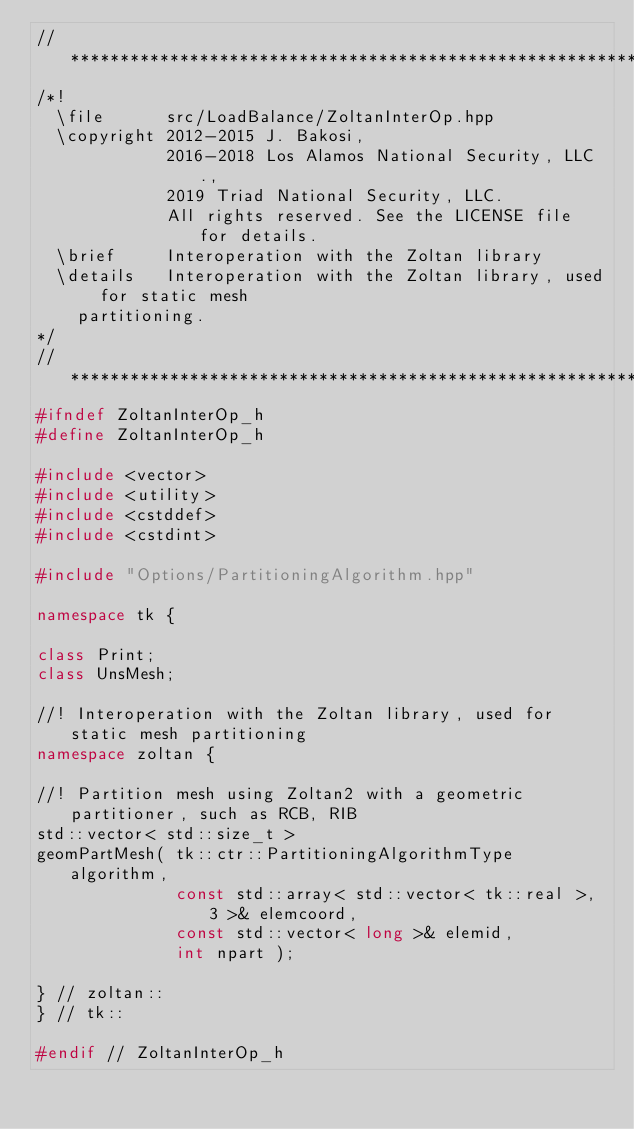<code> <loc_0><loc_0><loc_500><loc_500><_C++_>// *****************************************************************************
/*!
  \file      src/LoadBalance/ZoltanInterOp.hpp
  \copyright 2012-2015 J. Bakosi,
             2016-2018 Los Alamos National Security, LLC.,
             2019 Triad National Security, LLC.
             All rights reserved. See the LICENSE file for details.
  \brief     Interoperation with the Zoltan library
  \details   Interoperation with the Zoltan library, used for static mesh
    partitioning.
*/
// *****************************************************************************
#ifndef ZoltanInterOp_h
#define ZoltanInterOp_h

#include <vector>
#include <utility>
#include <cstddef>
#include <cstdint>

#include "Options/PartitioningAlgorithm.hpp"

namespace tk {

class Print;
class UnsMesh;

//! Interoperation with the Zoltan library, used for static mesh partitioning
namespace zoltan {

//! Partition mesh using Zoltan2 with a geometric partitioner, such as RCB, RIB
std::vector< std::size_t >
geomPartMesh( tk::ctr::PartitioningAlgorithmType algorithm,
              const std::array< std::vector< tk::real >, 3 >& elemcoord,
              const std::vector< long >& elemid,
              int npart );

} // zoltan::
} // tk::

#endif // ZoltanInterOp_h
</code> 